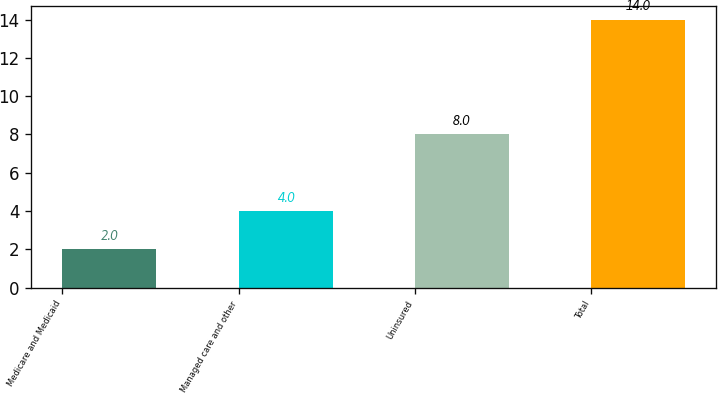Convert chart. <chart><loc_0><loc_0><loc_500><loc_500><bar_chart><fcel>Medicare and Medicaid<fcel>Managed care and other<fcel>Uninsured<fcel>Total<nl><fcel>2<fcel>4<fcel>8<fcel>14<nl></chart> 